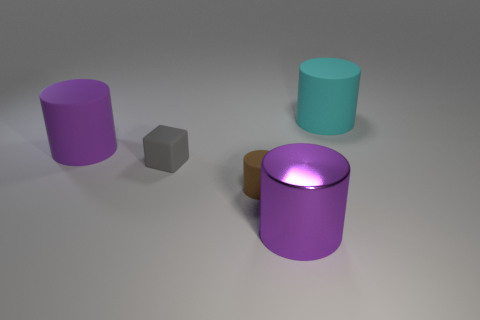What is the color of the large thing on the left side of the tiny gray matte object? purple 